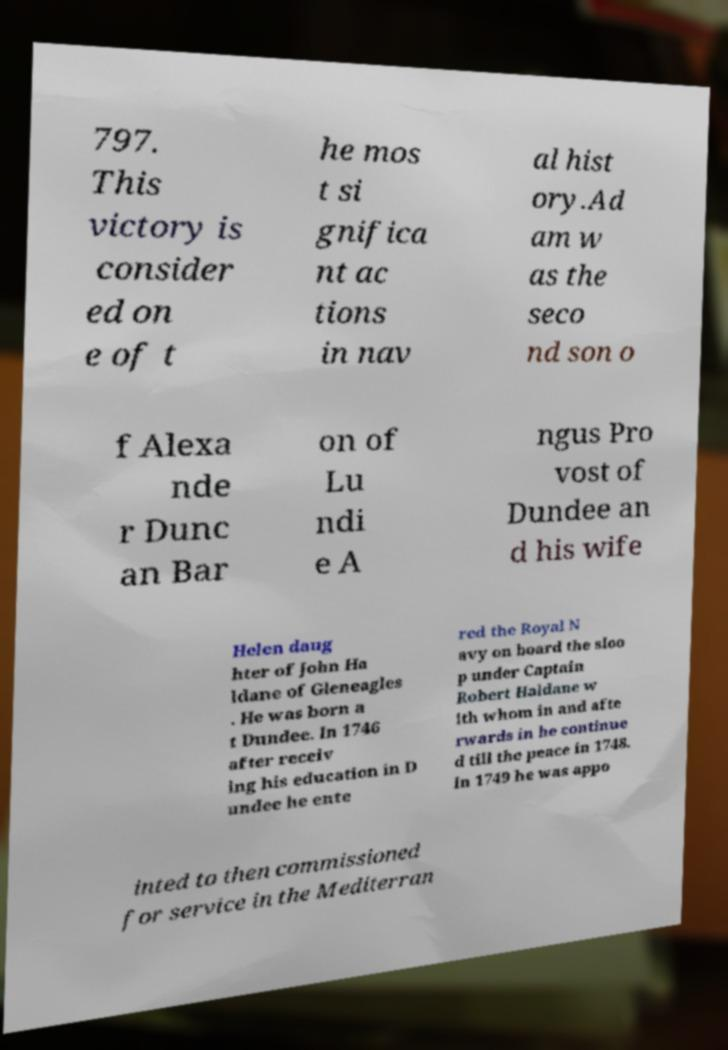Could you assist in decoding the text presented in this image and type it out clearly? 797. This victory is consider ed on e of t he mos t si gnifica nt ac tions in nav al hist ory.Ad am w as the seco nd son o f Alexa nde r Dunc an Bar on of Lu ndi e A ngus Pro vost of Dundee an d his wife Helen daug hter of John Ha ldane of Gleneagles . He was born a t Dundee. In 1746 after receiv ing his education in D undee he ente red the Royal N avy on board the sloo p under Captain Robert Haldane w ith whom in and afte rwards in he continue d till the peace in 1748. In 1749 he was appo inted to then commissioned for service in the Mediterran 